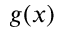<formula> <loc_0><loc_0><loc_500><loc_500>g ( x )</formula> 